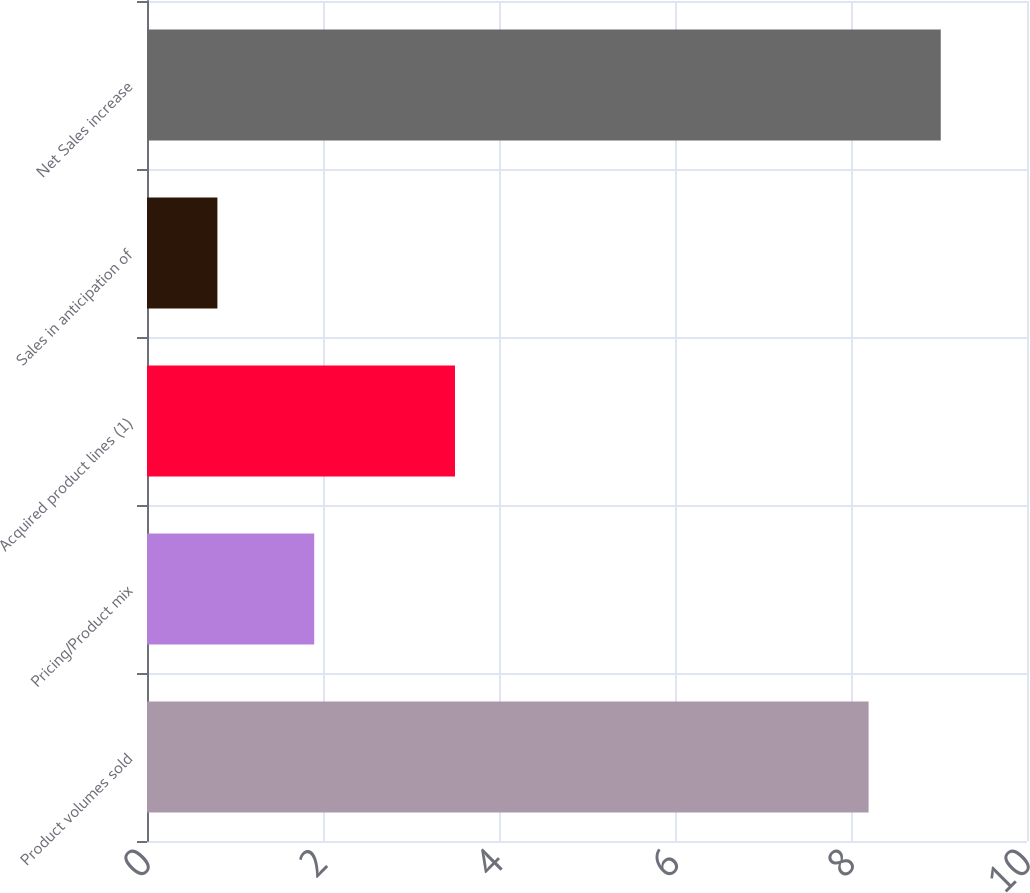Convert chart to OTSL. <chart><loc_0><loc_0><loc_500><loc_500><bar_chart><fcel>Product volumes sold<fcel>Pricing/Product mix<fcel>Acquired product lines (1)<fcel>Sales in anticipation of<fcel>Net Sales increase<nl><fcel>8.2<fcel>1.9<fcel>3.5<fcel>0.8<fcel>9.02<nl></chart> 